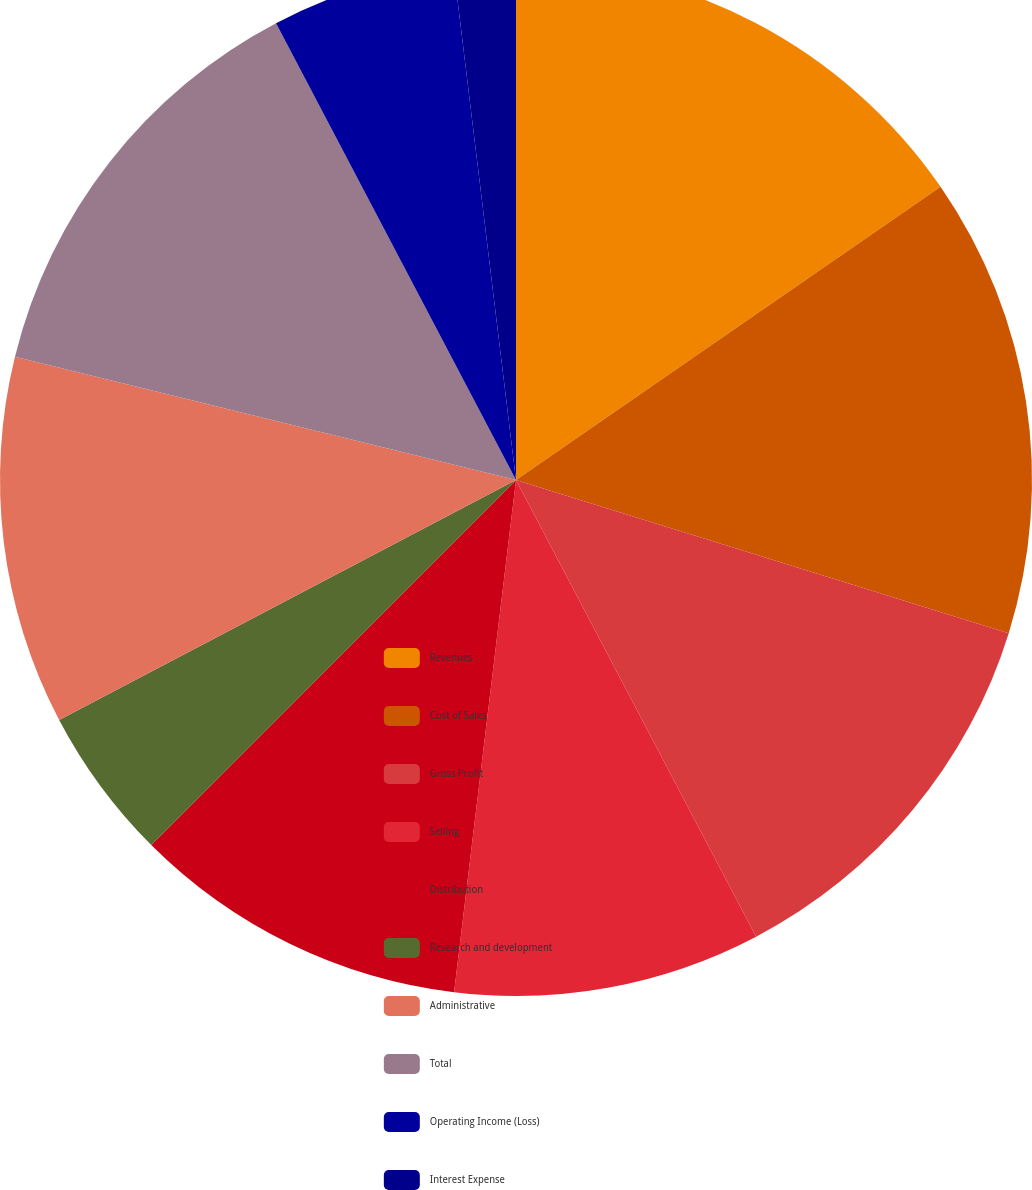Convert chart. <chart><loc_0><loc_0><loc_500><loc_500><pie_chart><fcel>Revenues<fcel>Cost of Sales<fcel>Gross Profit<fcel>Selling<fcel>Distribution<fcel>Research and development<fcel>Administrative<fcel>Total<fcel>Operating Income (Loss)<fcel>Interest Expense<nl><fcel>15.38%<fcel>14.42%<fcel>12.5%<fcel>9.62%<fcel>10.58%<fcel>4.81%<fcel>11.54%<fcel>13.46%<fcel>5.77%<fcel>1.93%<nl></chart> 